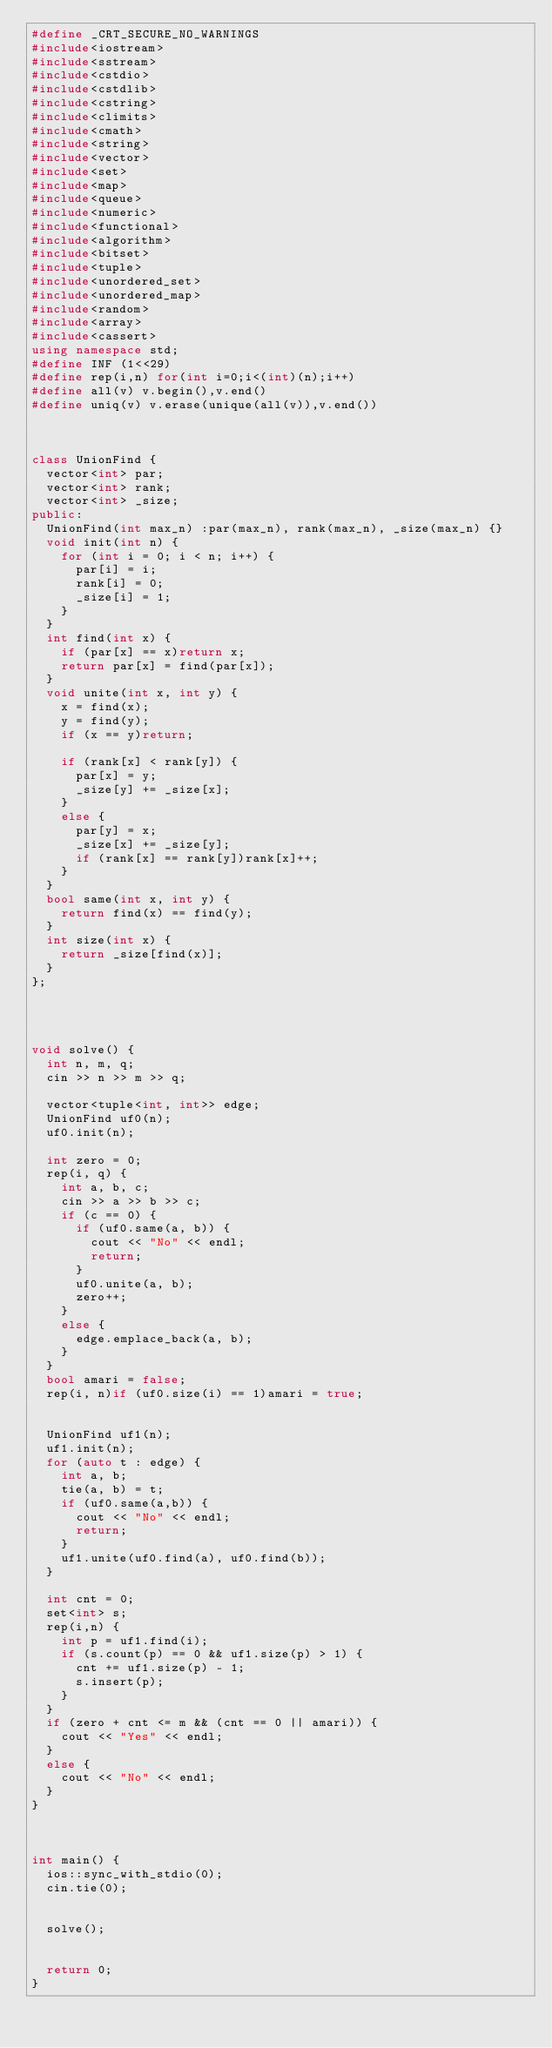<code> <loc_0><loc_0><loc_500><loc_500><_C++_>#define _CRT_SECURE_NO_WARNINGS
#include<iostream>
#include<sstream>
#include<cstdio>
#include<cstdlib>
#include<cstring>
#include<climits>
#include<cmath>
#include<string>
#include<vector>
#include<set>
#include<map>
#include<queue>
#include<numeric>
#include<functional>
#include<algorithm>
#include<bitset>
#include<tuple>
#include<unordered_set>
#include<unordered_map>
#include<random>
#include<array>
#include<cassert>
using namespace std;
#define INF (1<<29)
#define rep(i,n) for(int i=0;i<(int)(n);i++)
#define all(v) v.begin(),v.end()
#define uniq(v) v.erase(unique(all(v)),v.end())



class UnionFind {
	vector<int> par;
	vector<int> rank;
	vector<int> _size;
public:
	UnionFind(int max_n) :par(max_n), rank(max_n), _size(max_n) {}
	void init(int n) {
		for (int i = 0; i < n; i++) {
			par[i] = i;
			rank[i] = 0;
			_size[i] = 1;
		}
	}
	int find(int x) {
		if (par[x] == x)return x;
		return par[x] = find(par[x]);
	}
	void unite(int x, int y) {
		x = find(x);
		y = find(y);
		if (x == y)return;

		if (rank[x] < rank[y]) {
			par[x] = y;
			_size[y] += _size[x];
		}
		else {
			par[y] = x;
			_size[x] += _size[y];
			if (rank[x] == rank[y])rank[x]++;
		}
	}
	bool same(int x, int y) {
		return find(x) == find(y);
	}
	int size(int x) {
		return _size[find(x)];
	}
};




void solve() {
	int n, m, q;
	cin >> n >> m >> q;

	vector<tuple<int, int>> edge;
	UnionFind uf0(n);
	uf0.init(n);

	int zero = 0;
	rep(i, q) {
		int a, b, c;
		cin >> a >> b >> c;
		if (c == 0) {
			if (uf0.same(a, b)) {
				cout << "No" << endl;
				return;
			}
			uf0.unite(a, b);
			zero++;
		}
		else {
			edge.emplace_back(a, b);
		}
	}
	bool amari = false;
	rep(i, n)if (uf0.size(i) == 1)amari = true;


	UnionFind uf1(n);
	uf1.init(n);
	for (auto t : edge) {
		int a, b;
		tie(a, b) = t;
		if (uf0.same(a,b)) {
			cout << "No" << endl;
			return;
		}
		uf1.unite(uf0.find(a), uf0.find(b));
	}

	int cnt = 0;
	set<int> s;
	rep(i,n) {
		int p = uf1.find(i);
		if (s.count(p) == 0 && uf1.size(p) > 1) {
			cnt += uf1.size(p) - 1;
			s.insert(p);
		}
	}
	if (zero + cnt <= m && (cnt == 0 || amari)) {
		cout << "Yes" << endl;
	}
	else {
		cout << "No" << endl;
	}
}



int main() {
	ios::sync_with_stdio(0);
	cin.tie(0);


	solve();


	return 0;
}</code> 